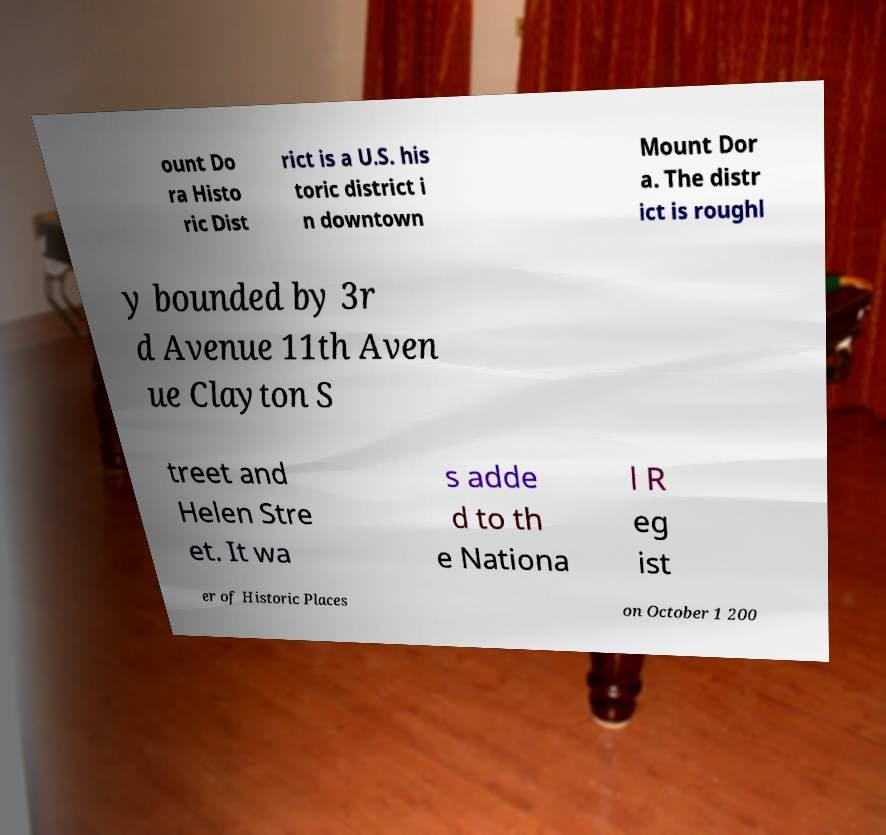What messages or text are displayed in this image? I need them in a readable, typed format. ount Do ra Histo ric Dist rict is a U.S. his toric district i n downtown Mount Dor a. The distr ict is roughl y bounded by 3r d Avenue 11th Aven ue Clayton S treet and Helen Stre et. It wa s adde d to th e Nationa l R eg ist er of Historic Places on October 1 200 